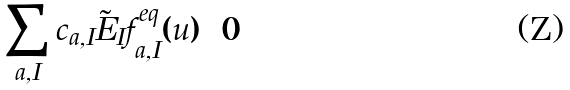<formula> <loc_0><loc_0><loc_500><loc_500>\sum _ { a , I } { c } _ { a , I } \tilde { E } _ { I } f ^ { e q } _ { a , I } ( { u } ) = 0</formula> 